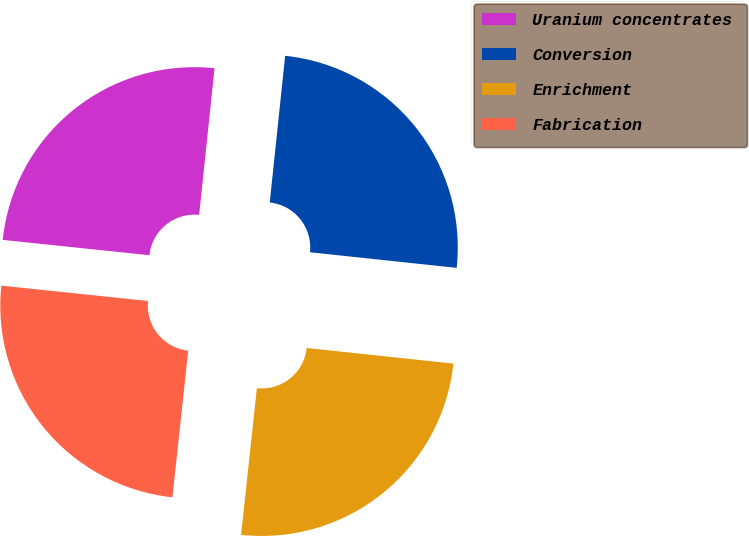Convert chart to OTSL. <chart><loc_0><loc_0><loc_500><loc_500><pie_chart><fcel>Uranium concentrates<fcel>Conversion<fcel>Enrichment<fcel>Fabrication<nl><fcel>25.01%<fcel>25.02%<fcel>25.02%<fcel>24.95%<nl></chart> 